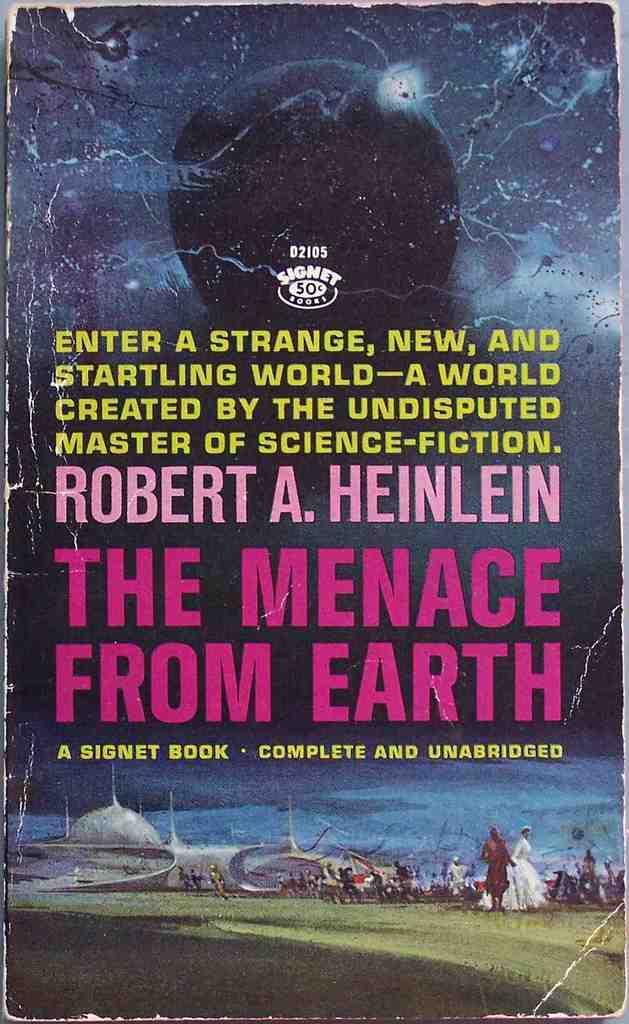<image>
Present a compact description of the photo's key features. Worn book cover for The Menace from Earth 